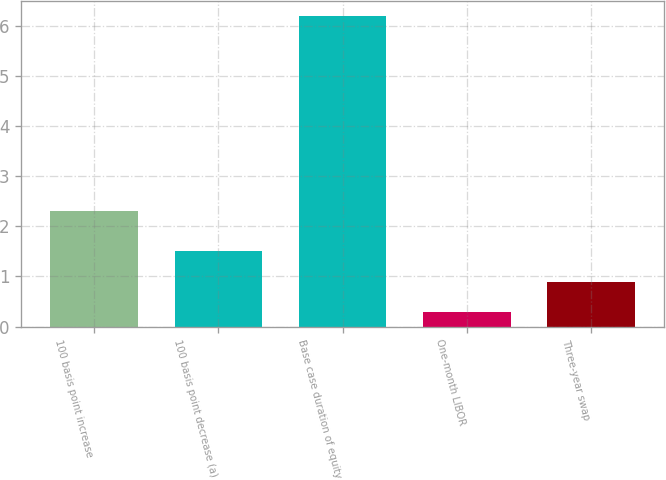Convert chart to OTSL. <chart><loc_0><loc_0><loc_500><loc_500><bar_chart><fcel>100 basis point increase<fcel>100 basis point decrease (a)<fcel>Base case duration of equity<fcel>One-month LIBOR<fcel>Three-year swap<nl><fcel>2.3<fcel>1.5<fcel>6.2<fcel>0.3<fcel>0.89<nl></chart> 